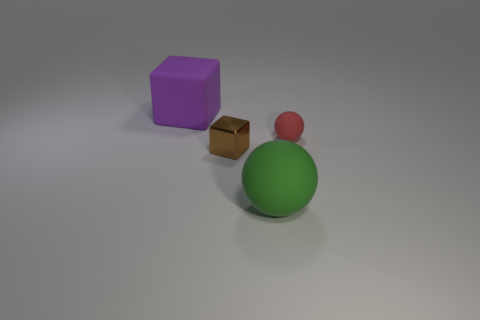There is a big thing that is in front of the small red thing; what shape is it?
Your answer should be compact. Sphere. The tiny metallic block has what color?
Make the answer very short. Brown. Does the purple matte block have the same size as the sphere that is behind the tiny brown block?
Your response must be concise. No. How many rubber objects are either big spheres or brown objects?
Keep it short and to the point. 1. Are there any other things that have the same material as the green thing?
Your response must be concise. Yes. There is a big rubber ball; does it have the same color as the tiny block in front of the red object?
Offer a terse response. No. What is the shape of the red object?
Your response must be concise. Sphere. There is a ball behind the large thing in front of the block that is behind the tiny rubber ball; what size is it?
Make the answer very short. Small. Do the large object behind the tiny matte ball and the big matte thing in front of the big purple rubber thing have the same shape?
Offer a terse response. No. What number of cylinders are red objects or brown metal things?
Keep it short and to the point. 0. 